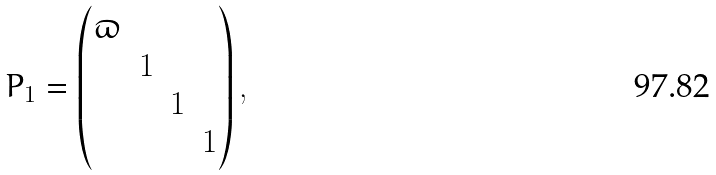<formula> <loc_0><loc_0><loc_500><loc_500>P _ { 1 } = \begin{pmatrix} \varpi & & & \\ & 1 & & \\ & & 1 & \\ & & & 1 \end{pmatrix} ,</formula> 